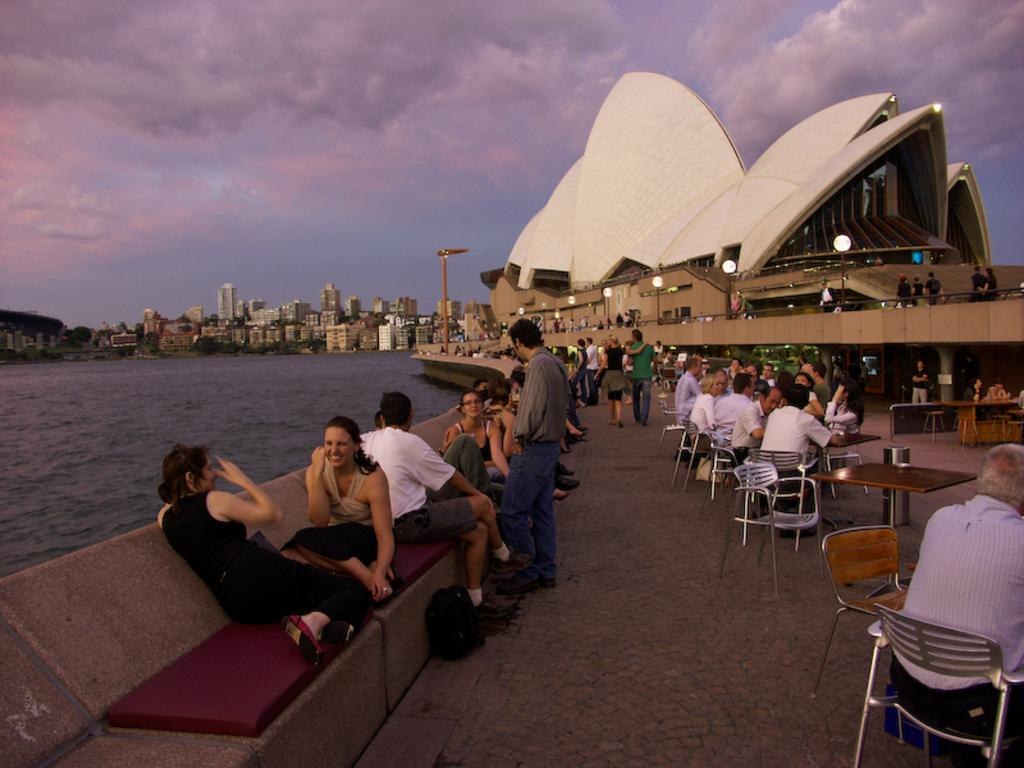How many people are in the image? There is a group of people in the image. What are some of the people in the image doing? Some people are seated on chairs, while others are standing. What can be seen in the background of the image? There is water, buildings, and lights visible in the background. What type of cake is being served to the son in the image? There is no son or cake present in the image. Is there a cord visible in the image? There is no cord visible in the image. 